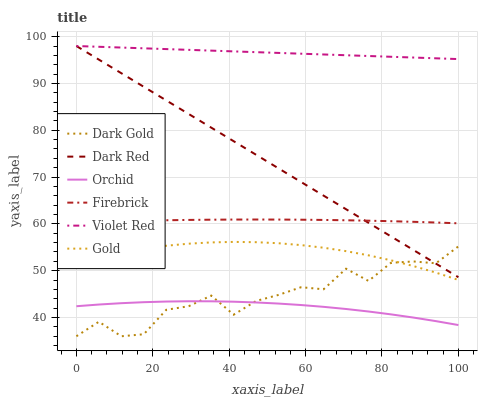Does Orchid have the minimum area under the curve?
Answer yes or no. Yes. Does Violet Red have the maximum area under the curve?
Answer yes or no. Yes. Does Gold have the minimum area under the curve?
Answer yes or no. No. Does Gold have the maximum area under the curve?
Answer yes or no. No. Is Violet Red the smoothest?
Answer yes or no. Yes. Is Dark Gold the roughest?
Answer yes or no. Yes. Is Gold the smoothest?
Answer yes or no. No. Is Gold the roughest?
Answer yes or no. No. Does Dark Gold have the lowest value?
Answer yes or no. Yes. Does Gold have the lowest value?
Answer yes or no. No. Does Dark Red have the highest value?
Answer yes or no. Yes. Does Gold have the highest value?
Answer yes or no. No. Is Gold less than Firebrick?
Answer yes or no. Yes. Is Violet Red greater than Orchid?
Answer yes or no. Yes. Does Dark Red intersect Dark Gold?
Answer yes or no. Yes. Is Dark Red less than Dark Gold?
Answer yes or no. No. Is Dark Red greater than Dark Gold?
Answer yes or no. No. Does Gold intersect Firebrick?
Answer yes or no. No. 